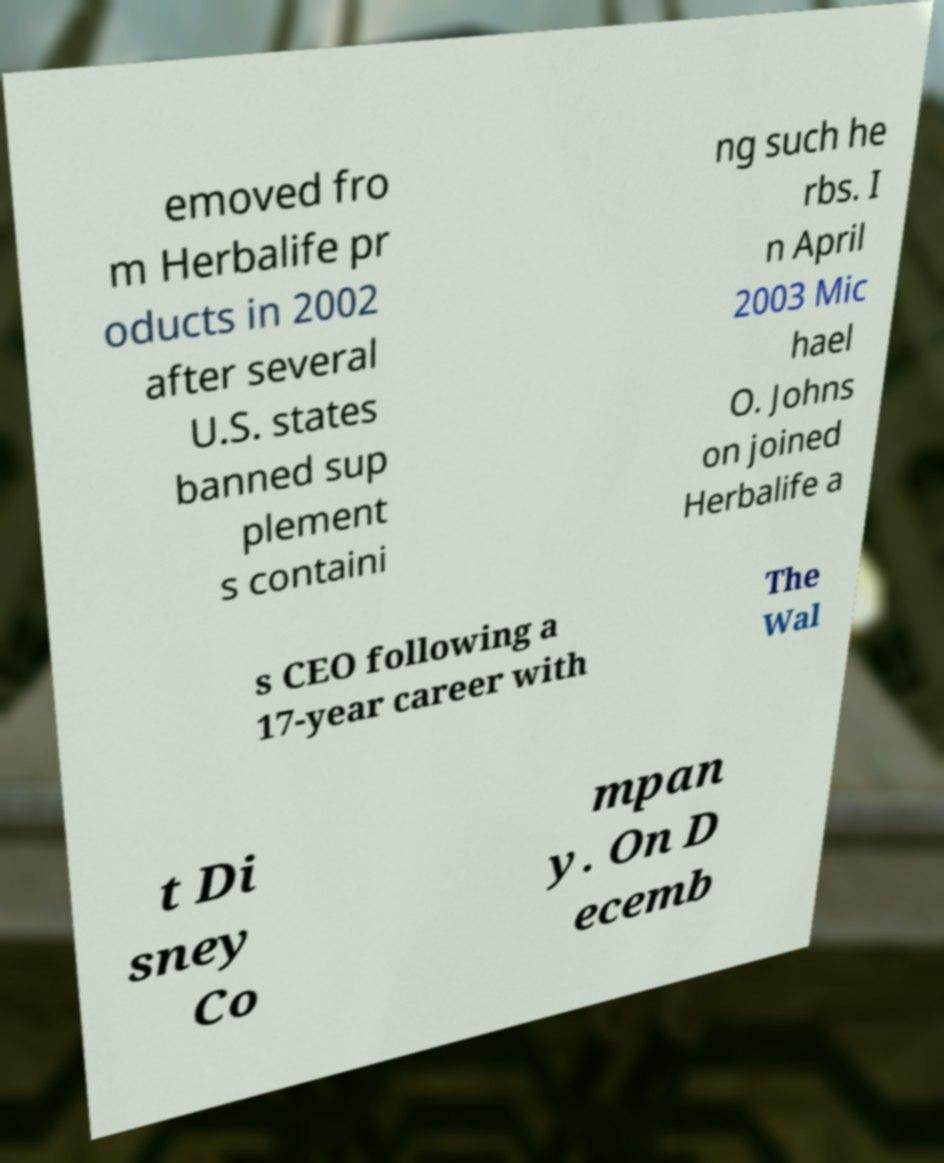I need the written content from this picture converted into text. Can you do that? emoved fro m Herbalife pr oducts in 2002 after several U.S. states banned sup plement s containi ng such he rbs. I n April 2003 Mic hael O. Johns on joined Herbalife a s CEO following a 17-year career with The Wal t Di sney Co mpan y. On D ecemb 